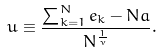Convert formula to latex. <formula><loc_0><loc_0><loc_500><loc_500>u \equiv \frac { \sum _ { k = 1 } ^ { N } e _ { k } - N a } { N ^ { \frac { 1 } { \nu } } } .</formula> 